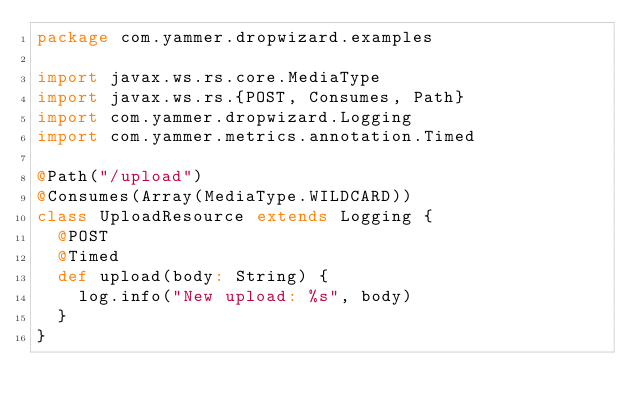Convert code to text. <code><loc_0><loc_0><loc_500><loc_500><_Scala_>package com.yammer.dropwizard.examples

import javax.ws.rs.core.MediaType
import javax.ws.rs.{POST, Consumes, Path}
import com.yammer.dropwizard.Logging
import com.yammer.metrics.annotation.Timed

@Path("/upload")
@Consumes(Array(MediaType.WILDCARD))
class UploadResource extends Logging {
  @POST
  @Timed
  def upload(body: String) {
    log.info("New upload: %s", body)
  }
}
</code> 